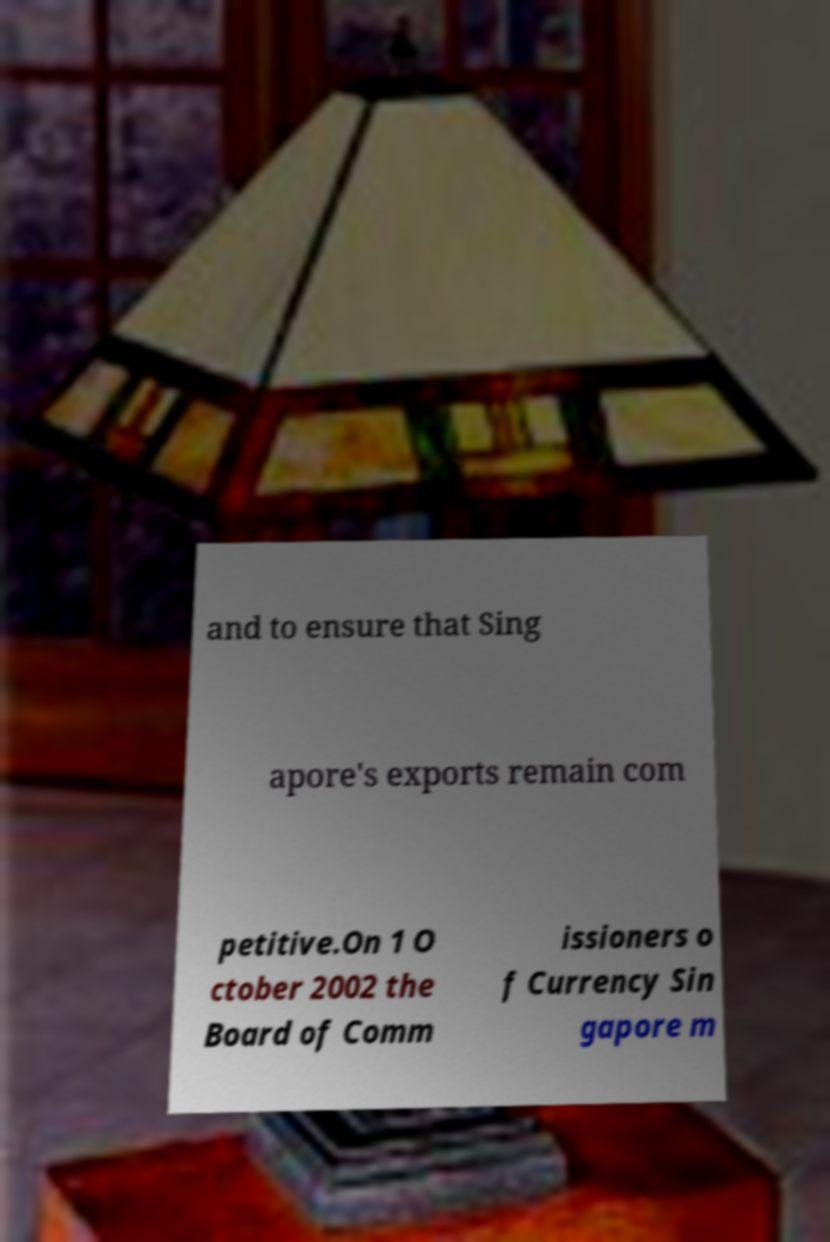Can you accurately transcribe the text from the provided image for me? and to ensure that Sing apore's exports remain com petitive.On 1 O ctober 2002 the Board of Comm issioners o f Currency Sin gapore m 